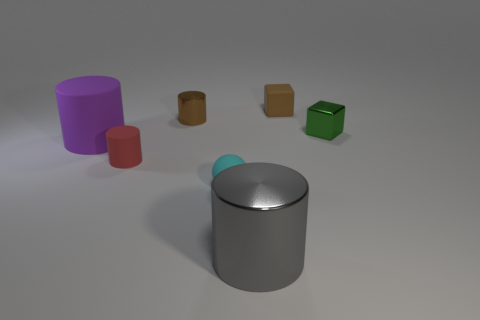Is the number of brown shiny cylinders greater than the number of small metallic balls? Upon examining the image, it appears that there is only one small metallic ball, which is less than the number of brown shiny cylinders present. Specifically, there are two cylinders that match the description of being brown and shiny. Therefore, the number of brown shiny cylinders is indeed greater than the single small metallic ball. 